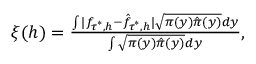<formula> <loc_0><loc_0><loc_500><loc_500>\begin{array} { r } { \xi ( h ) = \frac { \int | f _ { \tau ^ { * } , h } - \hat { f } _ { \tau ^ { * } , h } | \sqrt { \pi ( y ) \hat { \pi } ( y ) } d y } { \int \sqrt { \pi ( y ) \hat { \pi } ( y ) } d y } , } \end{array}</formula> 